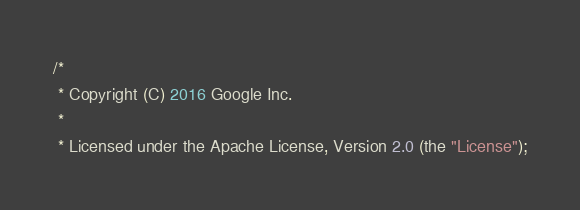Convert code to text. <code><loc_0><loc_0><loc_500><loc_500><_Java_>/*
 * Copyright (C) 2016 Google Inc.
 *
 * Licensed under the Apache License, Version 2.0 (the "License");</code> 